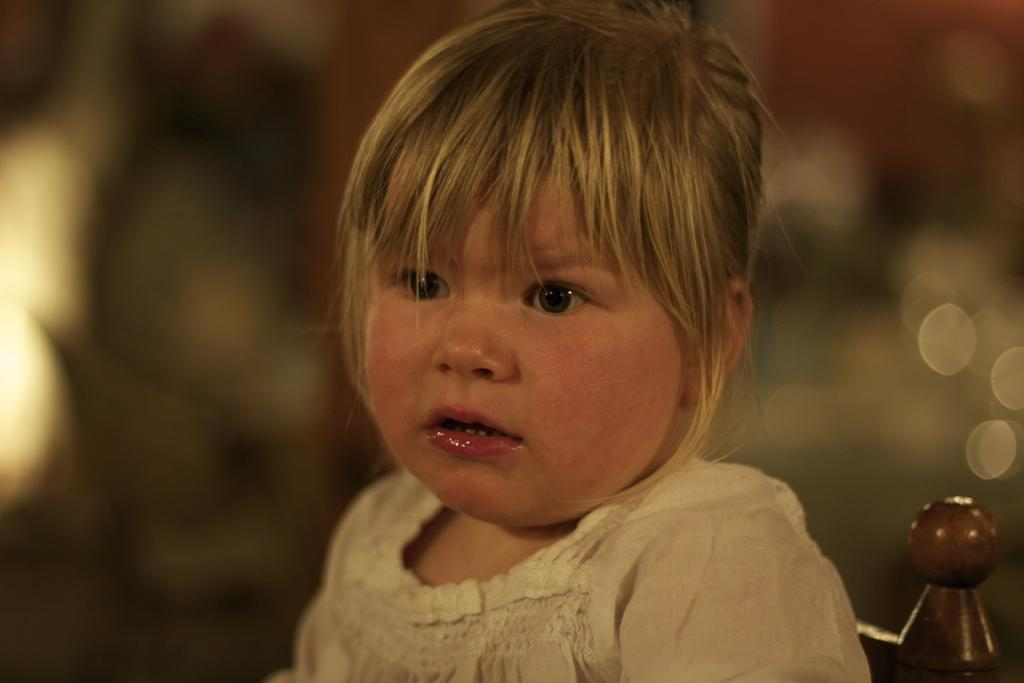What is the main subject of the image? There is a child in the image. Can you describe the child's attire? The child is wearing a white dress. What can be observed about the background of the image? The background of the image is completely blurred. What type of toothpaste is the child using in the image? There is no toothpaste present in the image; it features a child wearing a white dress with a blurred background. 